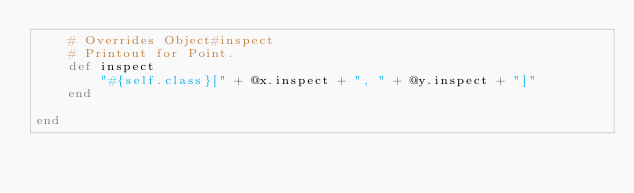Convert code to text. <code><loc_0><loc_0><loc_500><loc_500><_Ruby_>    # Overrides Object#inspect
    # Printout for Point.
    def inspect
        "#{self.class}[" + @x.inspect + ", " + @y.inspect + "]"
    end
    
end
</code> 